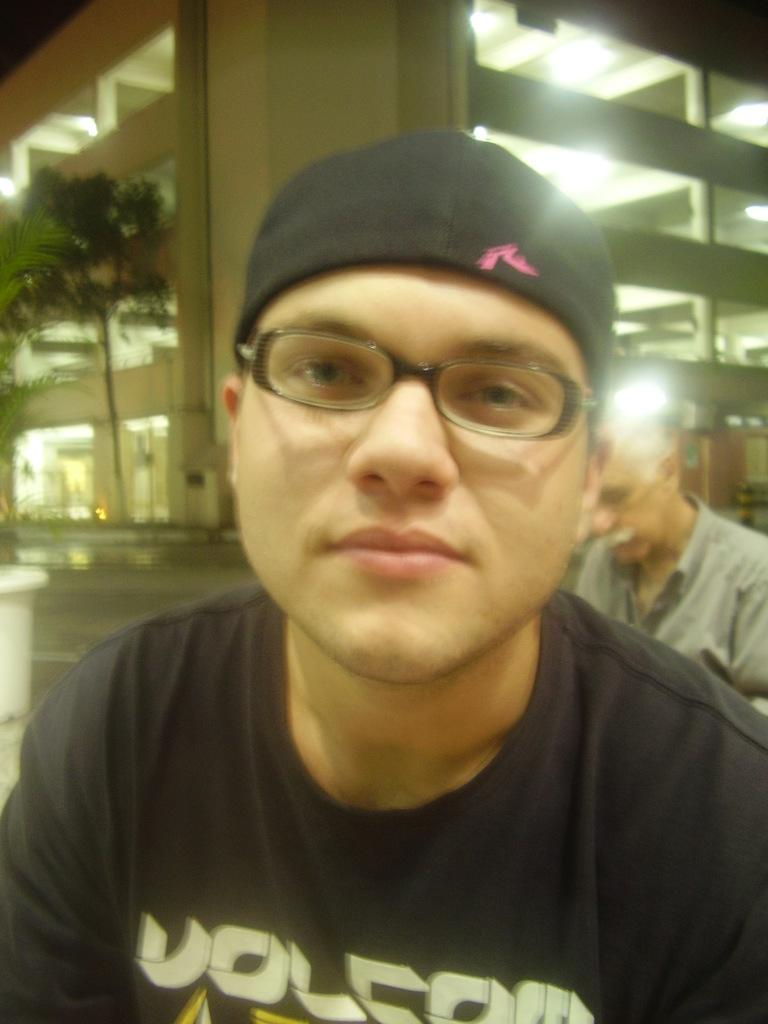How many people are in the image? There are people in the image, but the exact number is not specified. What type of surface is visible in the image? There is ground visible in the image. What type of plant can be seen in the image? There is a plant in a pot in the image. What type of natural element is present in the image? There is a tree in the image. What type of structure is visible in the image? There is a building with windows in the image. What architectural features can be seen in the building? There are pillars in the building. What type of illumination is present in the building? There are lights in the building. How many fingers can be seen on the van in the image? There is no van present in the image, and therefore no fingers can be seen on a van. What type of hook is attached to the tree in the image? There is no hook attached to the tree in the image. 